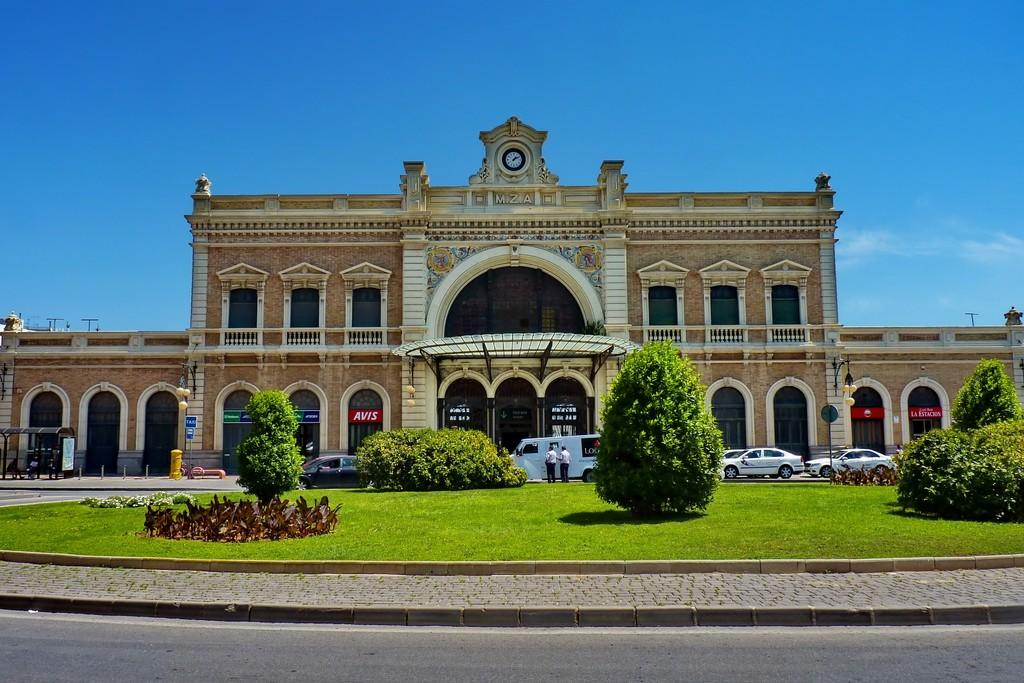<image>
Share a concise interpretation of the image provided. The large building has a sign for Avis hanging in one of the archways. 